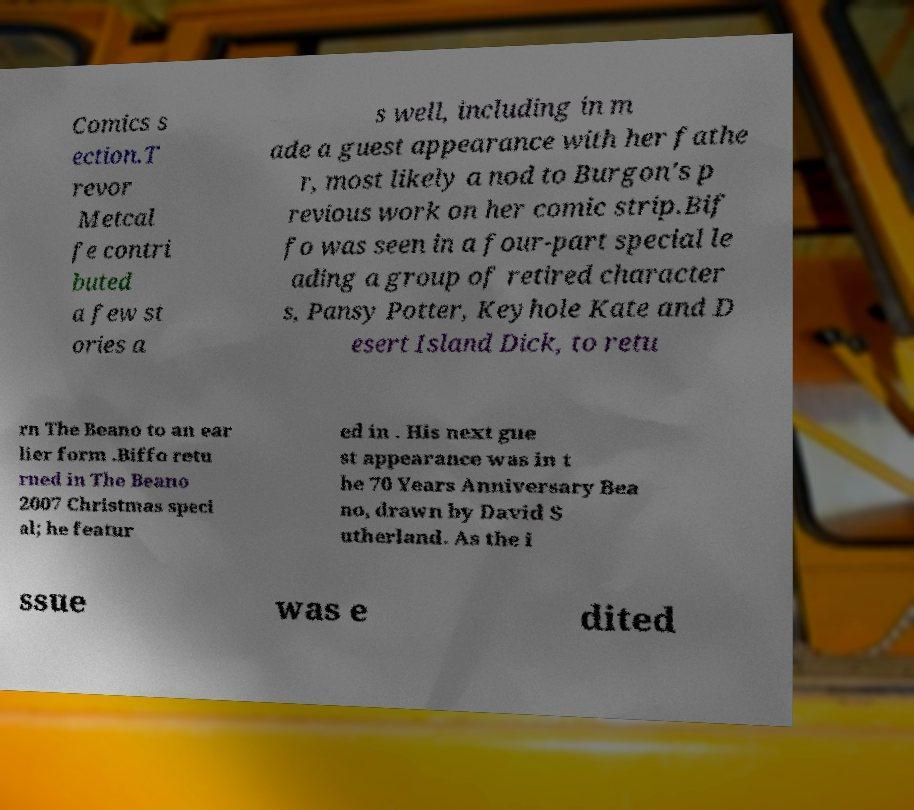Could you assist in decoding the text presented in this image and type it out clearly? Comics s ection.T revor Metcal fe contri buted a few st ories a s well, including in m ade a guest appearance with her fathe r, most likely a nod to Burgon's p revious work on her comic strip.Bif fo was seen in a four-part special le ading a group of retired character s, Pansy Potter, Keyhole Kate and D esert Island Dick, to retu rn The Beano to an ear lier form .Biffo retu rned in The Beano 2007 Christmas speci al; he featur ed in . His next gue st appearance was in t he 70 Years Anniversary Bea no, drawn by David S utherland. As the i ssue was e dited 